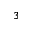<formula> <loc_0><loc_0><loc_500><loc_500>_ { 3 }</formula> 